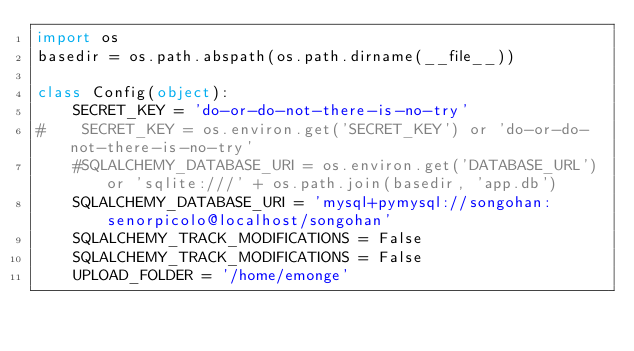<code> <loc_0><loc_0><loc_500><loc_500><_Python_>import os
basedir = os.path.abspath(os.path.dirname(__file__))

class Config(object):
    SECRET_KEY = 'do-or-do-not-there-is-no-try'
#    SECRET_KEY = os.environ.get('SECRET_KEY') or 'do-or-do-not-there-is-no-try'
    #SQLALCHEMY_DATABASE_URI = os.environ.get('DATABASE_URL') or 'sqlite:///' + os.path.join(basedir, 'app.db')
    SQLALCHEMY_DATABASE_URI = 'mysql+pymysql://songohan:senorpicolo@localhost/songohan' 
    SQLALCHEMY_TRACK_MODIFICATIONS = False
    SQLALCHEMY_TRACK_MODIFICATIONS = False
    UPLOAD_FOLDER = '/home/emonge'
</code> 